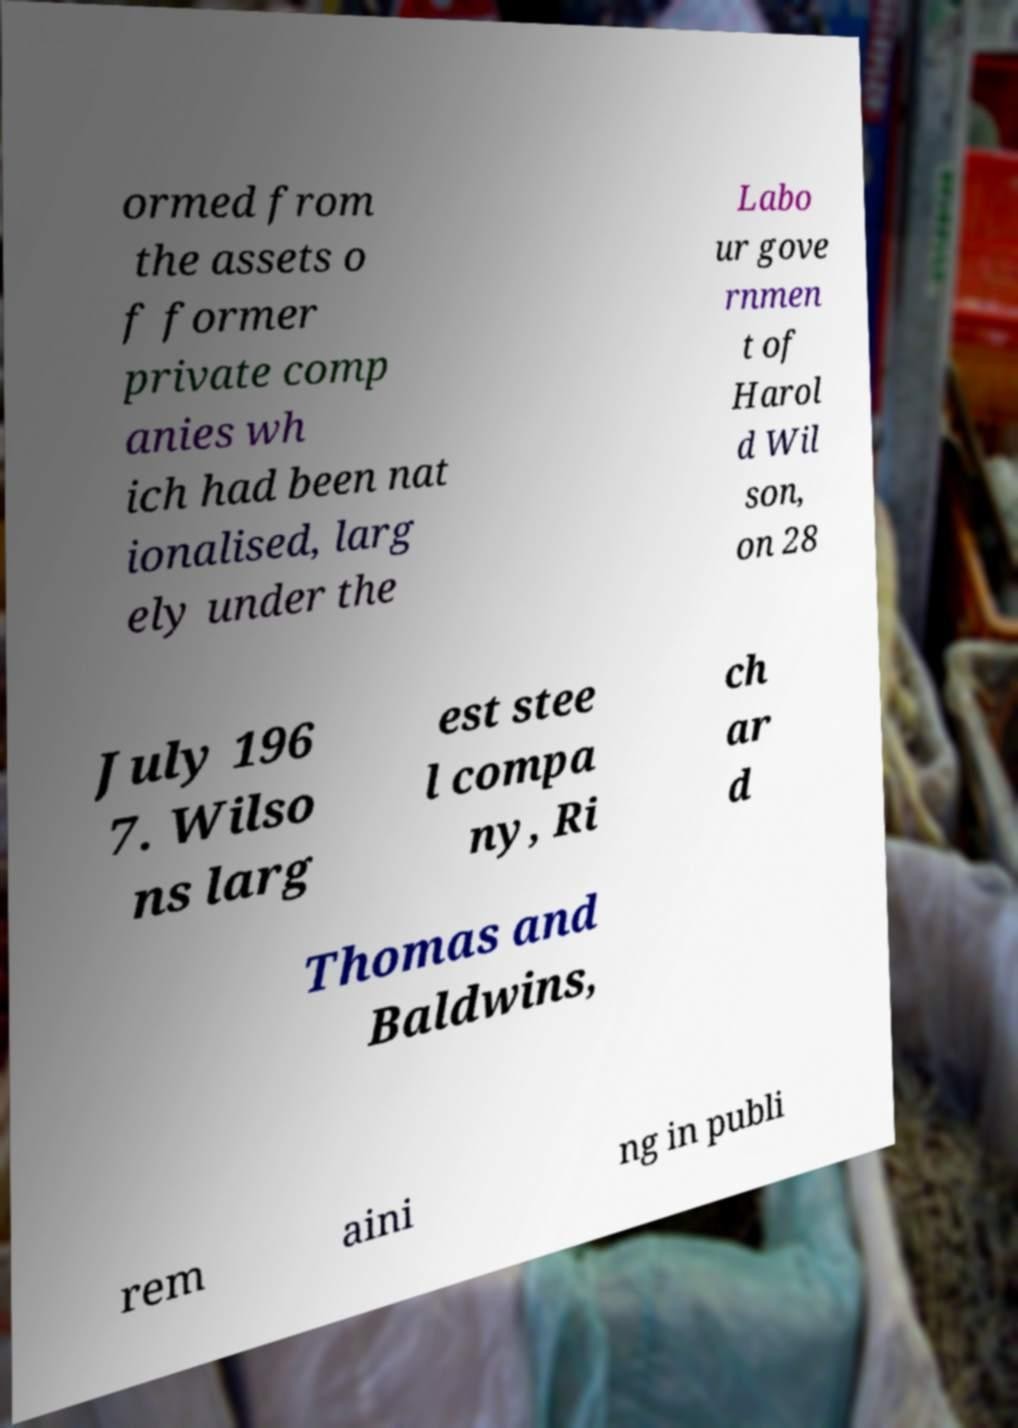Could you extract and type out the text from this image? ormed from the assets o f former private comp anies wh ich had been nat ionalised, larg ely under the Labo ur gove rnmen t of Harol d Wil son, on 28 July 196 7. Wilso ns larg est stee l compa ny, Ri ch ar d Thomas and Baldwins, rem aini ng in publi 